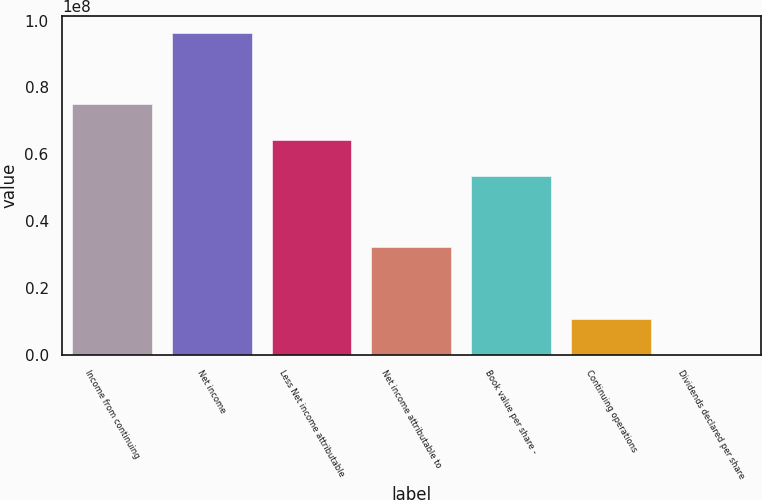Convert chart to OTSL. <chart><loc_0><loc_0><loc_500><loc_500><bar_chart><fcel>Income from continuing<fcel>Net income<fcel>Less Net income attributable<fcel>Net income attributable to<fcel>Book value per share -<fcel>Continuing operations<fcel>Dividends declared per share<nl><fcel>7.49965e+07<fcel>9.6424e+07<fcel>6.42827e+07<fcel>3.21413e+07<fcel>5.35689e+07<fcel>1.07138e+07<fcel>2.1<nl></chart> 